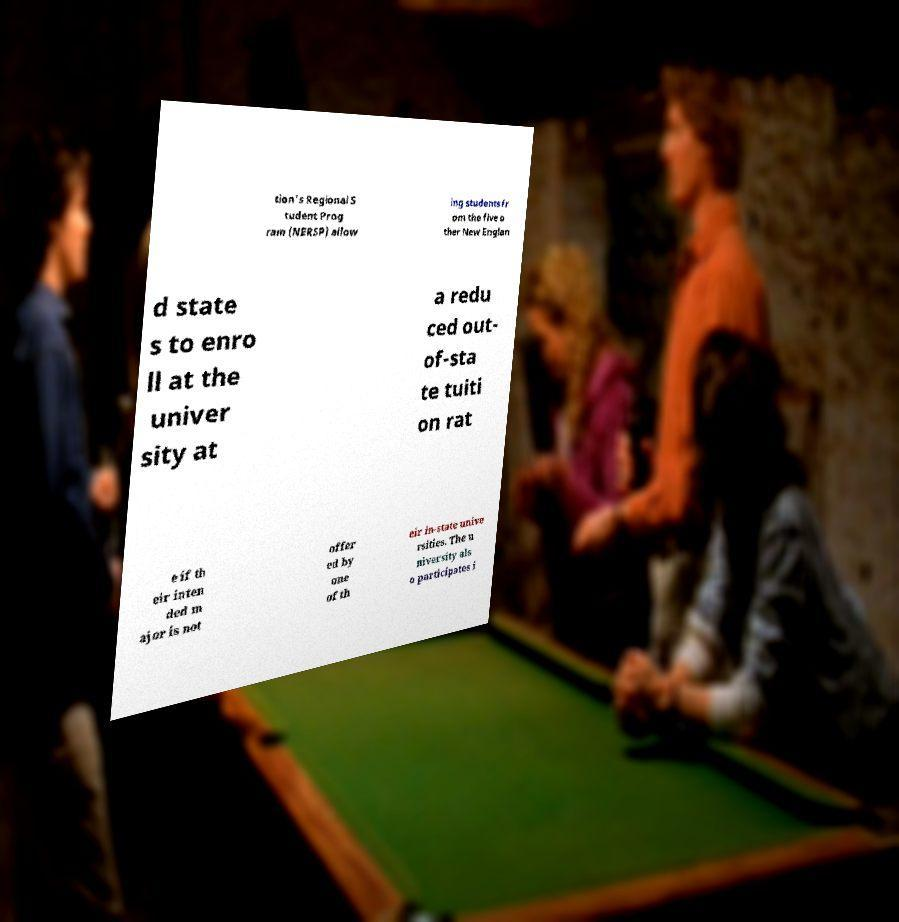I need the written content from this picture converted into text. Can you do that? tion's Regional S tudent Prog ram (NERSP) allow ing students fr om the five o ther New Englan d state s to enro ll at the univer sity at a redu ced out- of-sta te tuiti on rat e if th eir inten ded m ajor is not offer ed by one of th eir in-state unive rsities. The u niversity als o participates i 